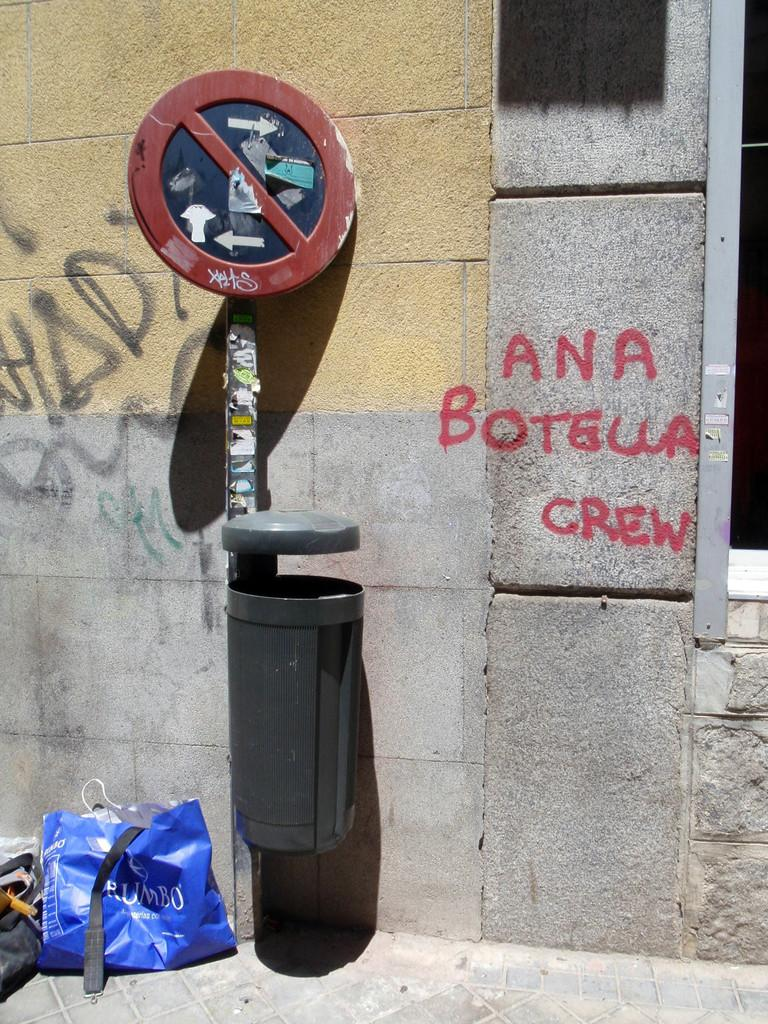<image>
Create a compact narrative representing the image presented. Ana Botella Crew is spray painted on a wall. 